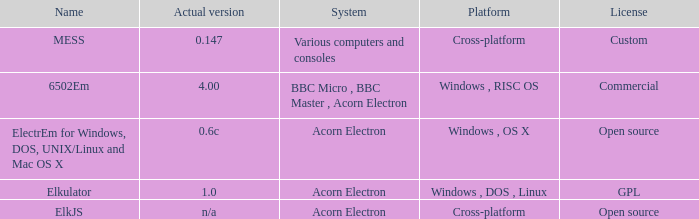Which system is named ELKJS? Acorn Electron. 